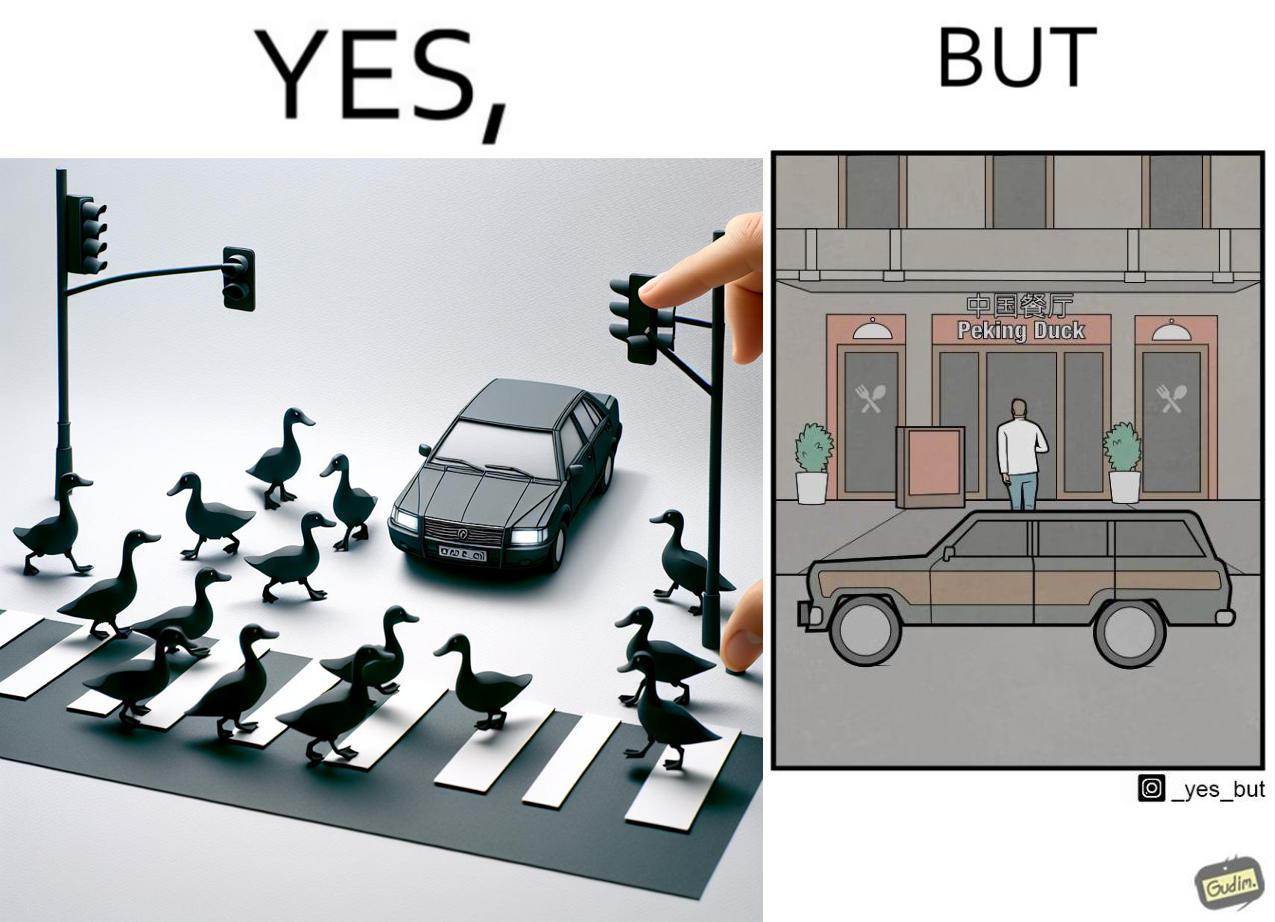Provide a description of this image. The images are ironic since they show how a man supposedly cares for ducks since he stops his vehicle to give way to queue of ducks allowing them to safely cross a road but on the other hand he goes to a peking duck shop to buy and eat similar ducks after having them killed 